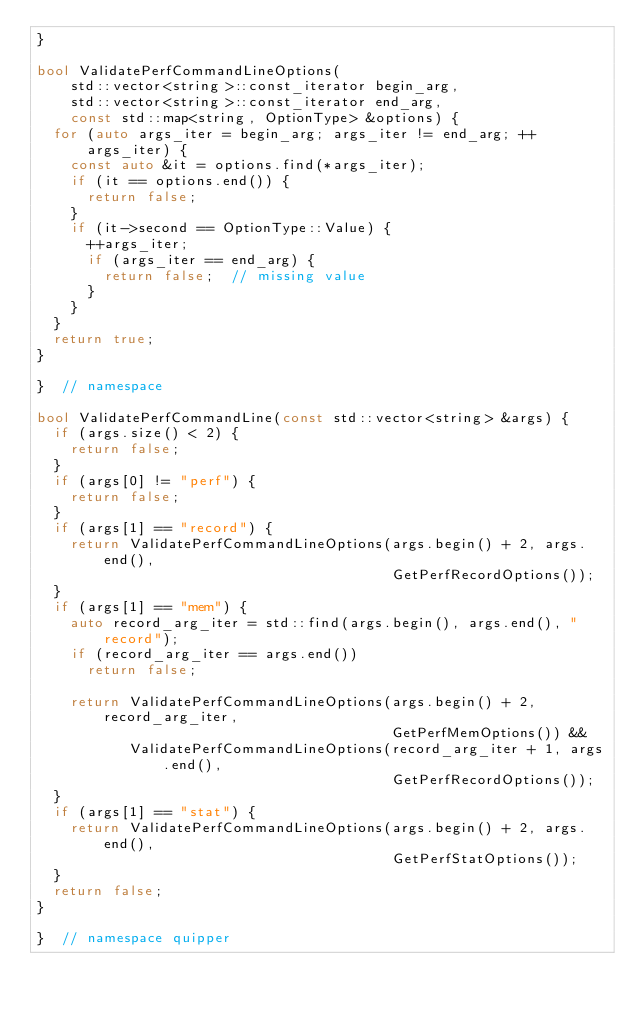Convert code to text. <code><loc_0><loc_0><loc_500><loc_500><_C++_>}

bool ValidatePerfCommandLineOptions(
    std::vector<string>::const_iterator begin_arg,
    std::vector<string>::const_iterator end_arg,
    const std::map<string, OptionType> &options) {
  for (auto args_iter = begin_arg; args_iter != end_arg; ++args_iter) {
    const auto &it = options.find(*args_iter);
    if (it == options.end()) {
      return false;
    }
    if (it->second == OptionType::Value) {
      ++args_iter;
      if (args_iter == end_arg) {
        return false;  // missing value
      }
    }
  }
  return true;
}

}  // namespace

bool ValidatePerfCommandLine(const std::vector<string> &args) {
  if (args.size() < 2) {
    return false;
  }
  if (args[0] != "perf") {
    return false;
  }
  if (args[1] == "record") {
    return ValidatePerfCommandLineOptions(args.begin() + 2, args.end(),
                                          GetPerfRecordOptions());
  }
  if (args[1] == "mem") {
    auto record_arg_iter = std::find(args.begin(), args.end(), "record");
    if (record_arg_iter == args.end())
      return false;

    return ValidatePerfCommandLineOptions(args.begin() + 2, record_arg_iter,
                                          GetPerfMemOptions()) &&
           ValidatePerfCommandLineOptions(record_arg_iter + 1, args.end(),
                                          GetPerfRecordOptions());
  }
  if (args[1] == "stat") {
    return ValidatePerfCommandLineOptions(args.begin() + 2, args.end(),
                                          GetPerfStatOptions());
  }
  return false;
}

}  // namespace quipper
</code> 